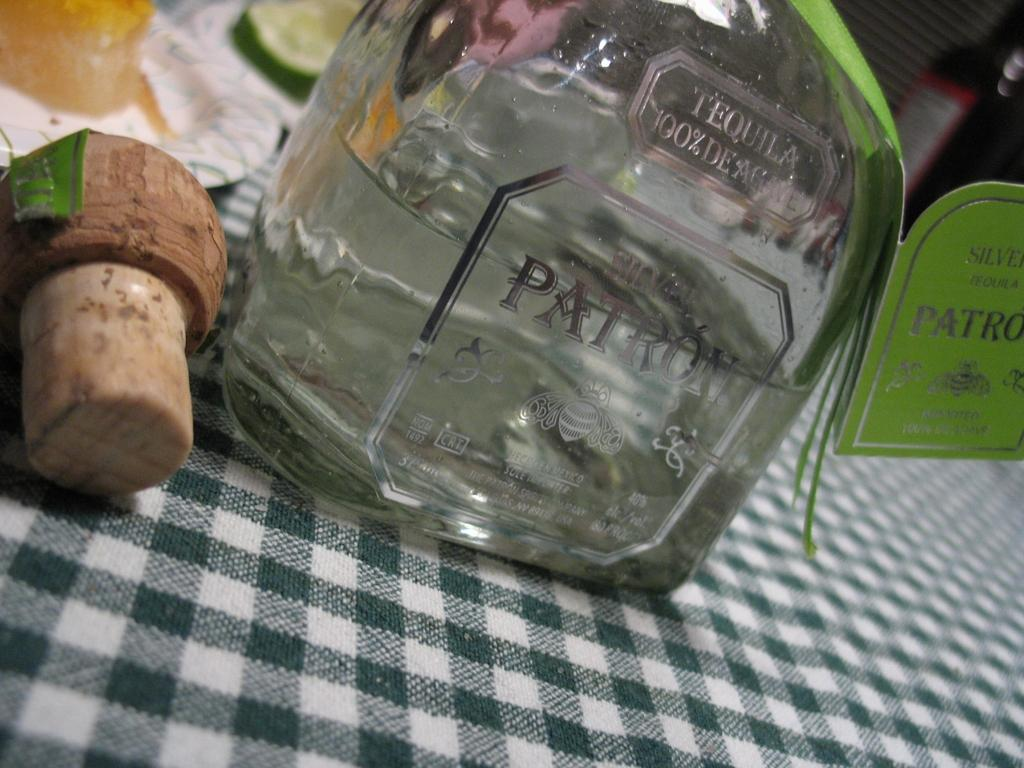What is one of the objects on the table in the image? There is a bottle on the table in the image. What else can be seen on the table in the image? There is a plate and cucumber on the table in the image. What type of material is the cloth made of in the image? The cloth in the image is made of a material that is not specified. Where are all of these items located in the image? All of these items are on a table in the image. What type of flower is on the table in the image? There is no flower present on the table in the image. What language is being spoken by the people in the image? There are no people present in the image, so it is not possible to determine what language is being spoken. 